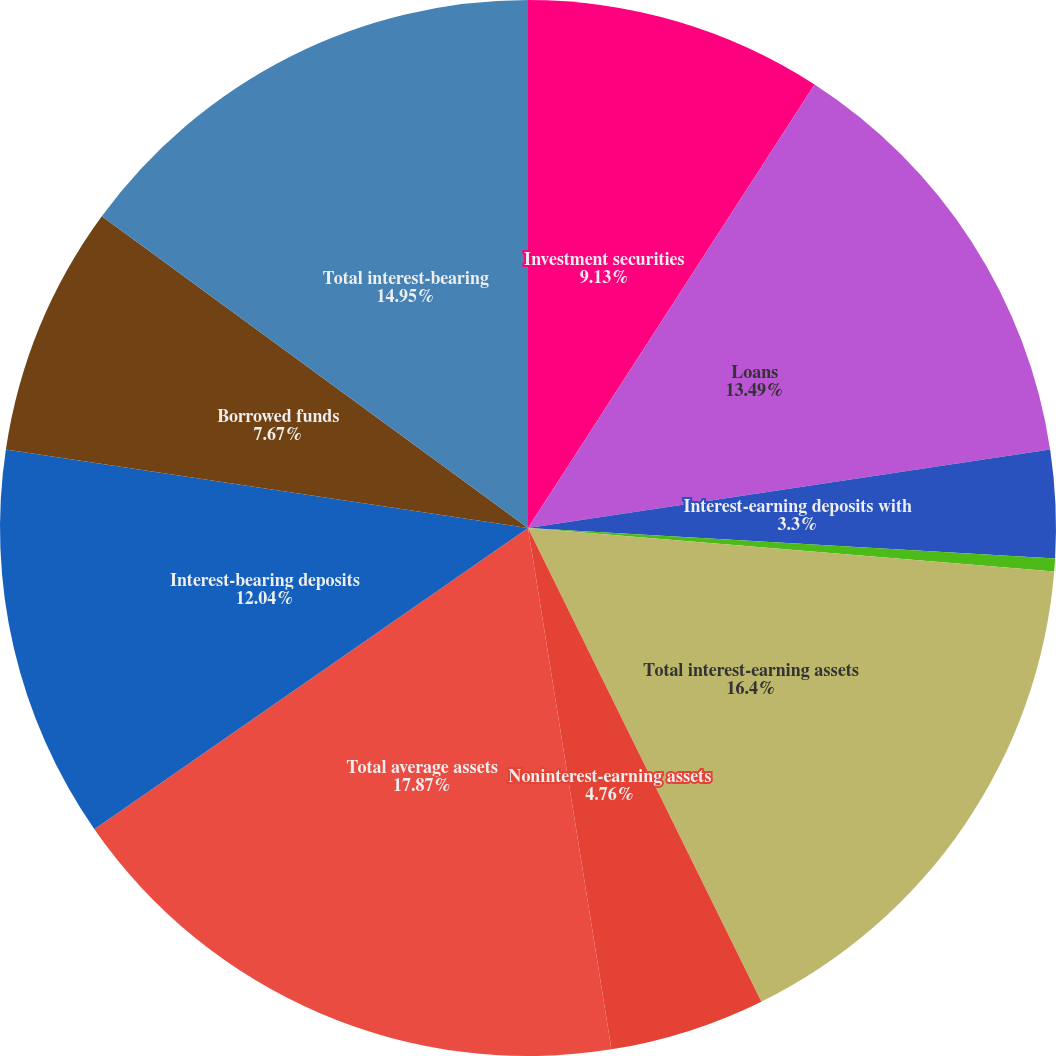Convert chart. <chart><loc_0><loc_0><loc_500><loc_500><pie_chart><fcel>Investment securities<fcel>Loans<fcel>Interest-earning deposits with<fcel>Other<fcel>Total interest-earning assets<fcel>Noninterest-earning assets<fcel>Total average assets<fcel>Interest-bearing deposits<fcel>Borrowed funds<fcel>Total interest-bearing<nl><fcel>9.13%<fcel>13.49%<fcel>3.3%<fcel>0.39%<fcel>16.4%<fcel>4.76%<fcel>17.86%<fcel>12.04%<fcel>7.67%<fcel>14.95%<nl></chart> 